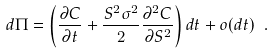Convert formula to latex. <formula><loc_0><loc_0><loc_500><loc_500>d \Pi = \left ( \frac { \partial C } { \partial t } + \frac { S ^ { 2 } \sigma ^ { 2 } } { 2 } \frac { \partial ^ { 2 } C } { \partial S ^ { 2 } } \right ) d t + o ( d t ) \ .</formula> 